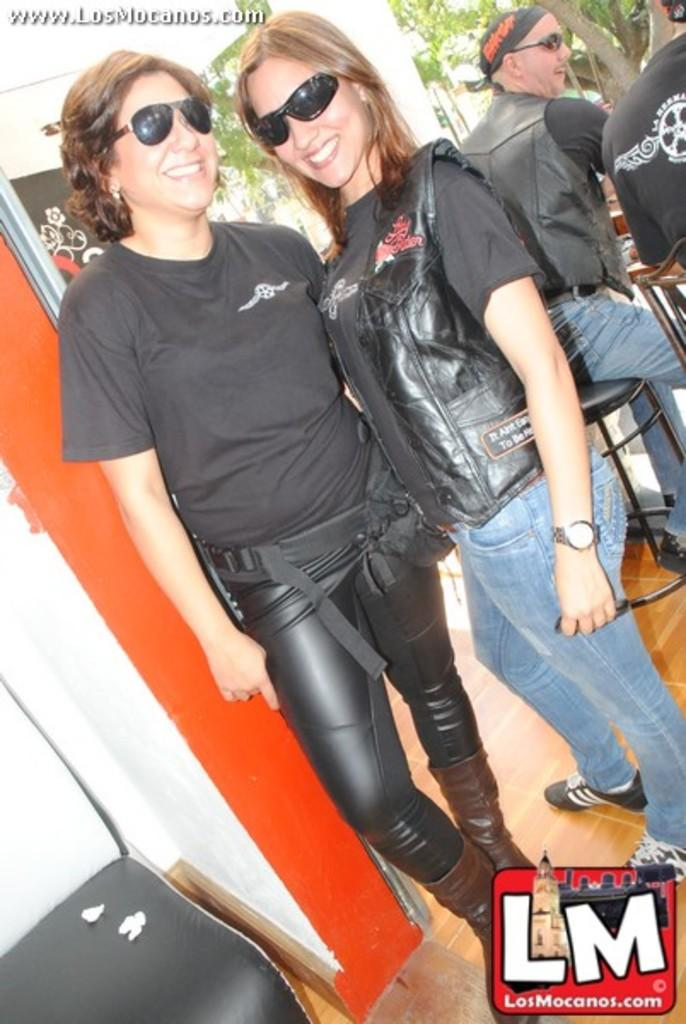How many people are posing for a photo in the image? There are two people standing and posing for a photo in the image. What else can be seen in the background of the image? There are other people visible in the background, as well as trees and a pillar. Can you describe the setting of the photo? The image appears to be taken from a website, and the background features trees and a pillar, suggesting an outdoor location. What type of grape is being harvested in the background of the image? There is no grape or grape harvesting activity visible in the image; it features two people posing for a photo and a background with trees and a pillar. 